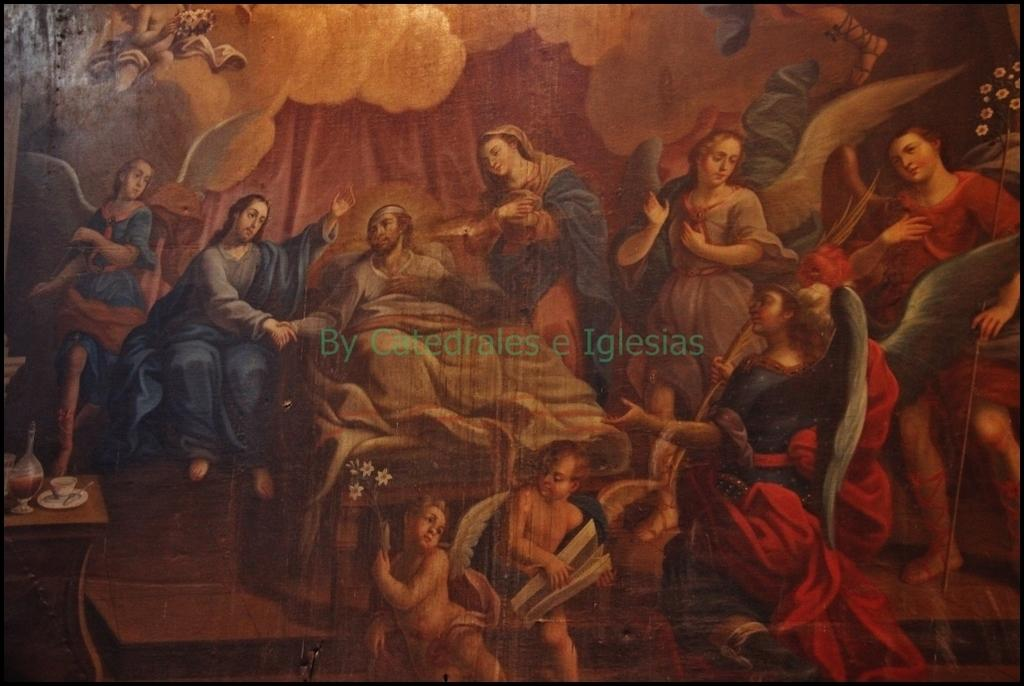What is the main subject of the painting? The main subject of the painting is a person lying on the bed. Are there any other people in the painting? Yes, there are women and children in the painting. Where are all the individuals in the painting located? All the individuals are on the bed. What type of pan is being used to cook the bone in the painting? There is no pan or bone present in the painting; it only features individuals lying on a bed. 